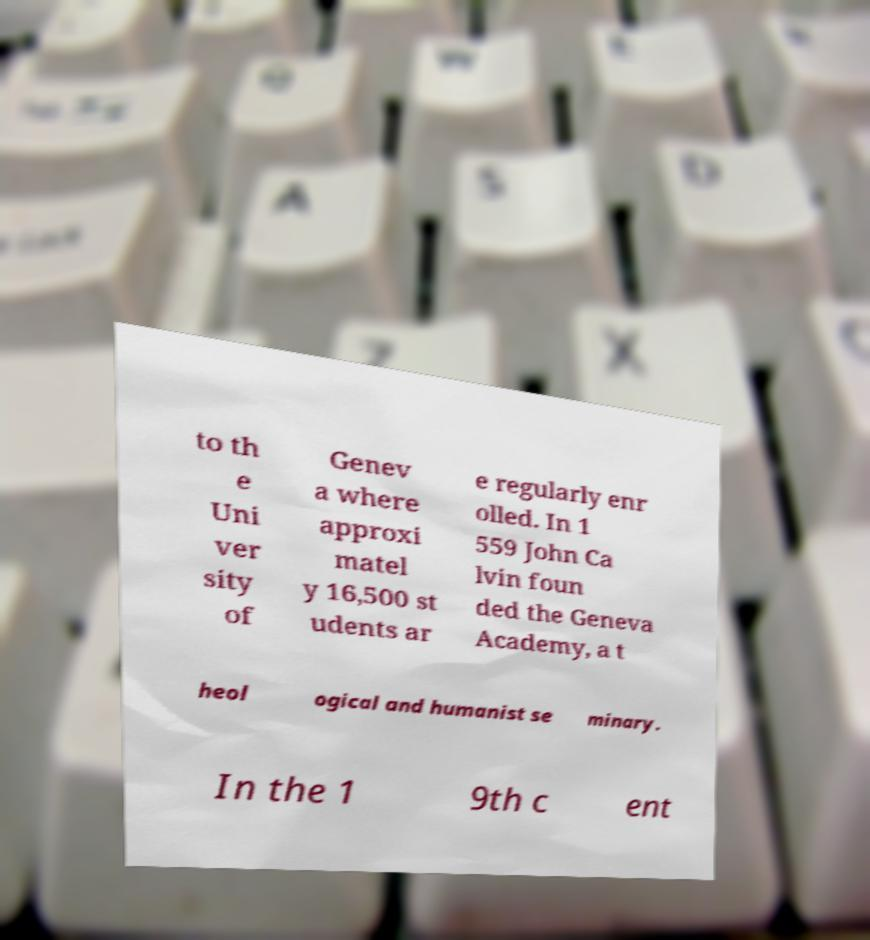Could you extract and type out the text from this image? to th e Uni ver sity of Genev a where approxi matel y 16,500 st udents ar e regularly enr olled. In 1 559 John Ca lvin foun ded the Geneva Academy, a t heol ogical and humanist se minary. In the 1 9th c ent 